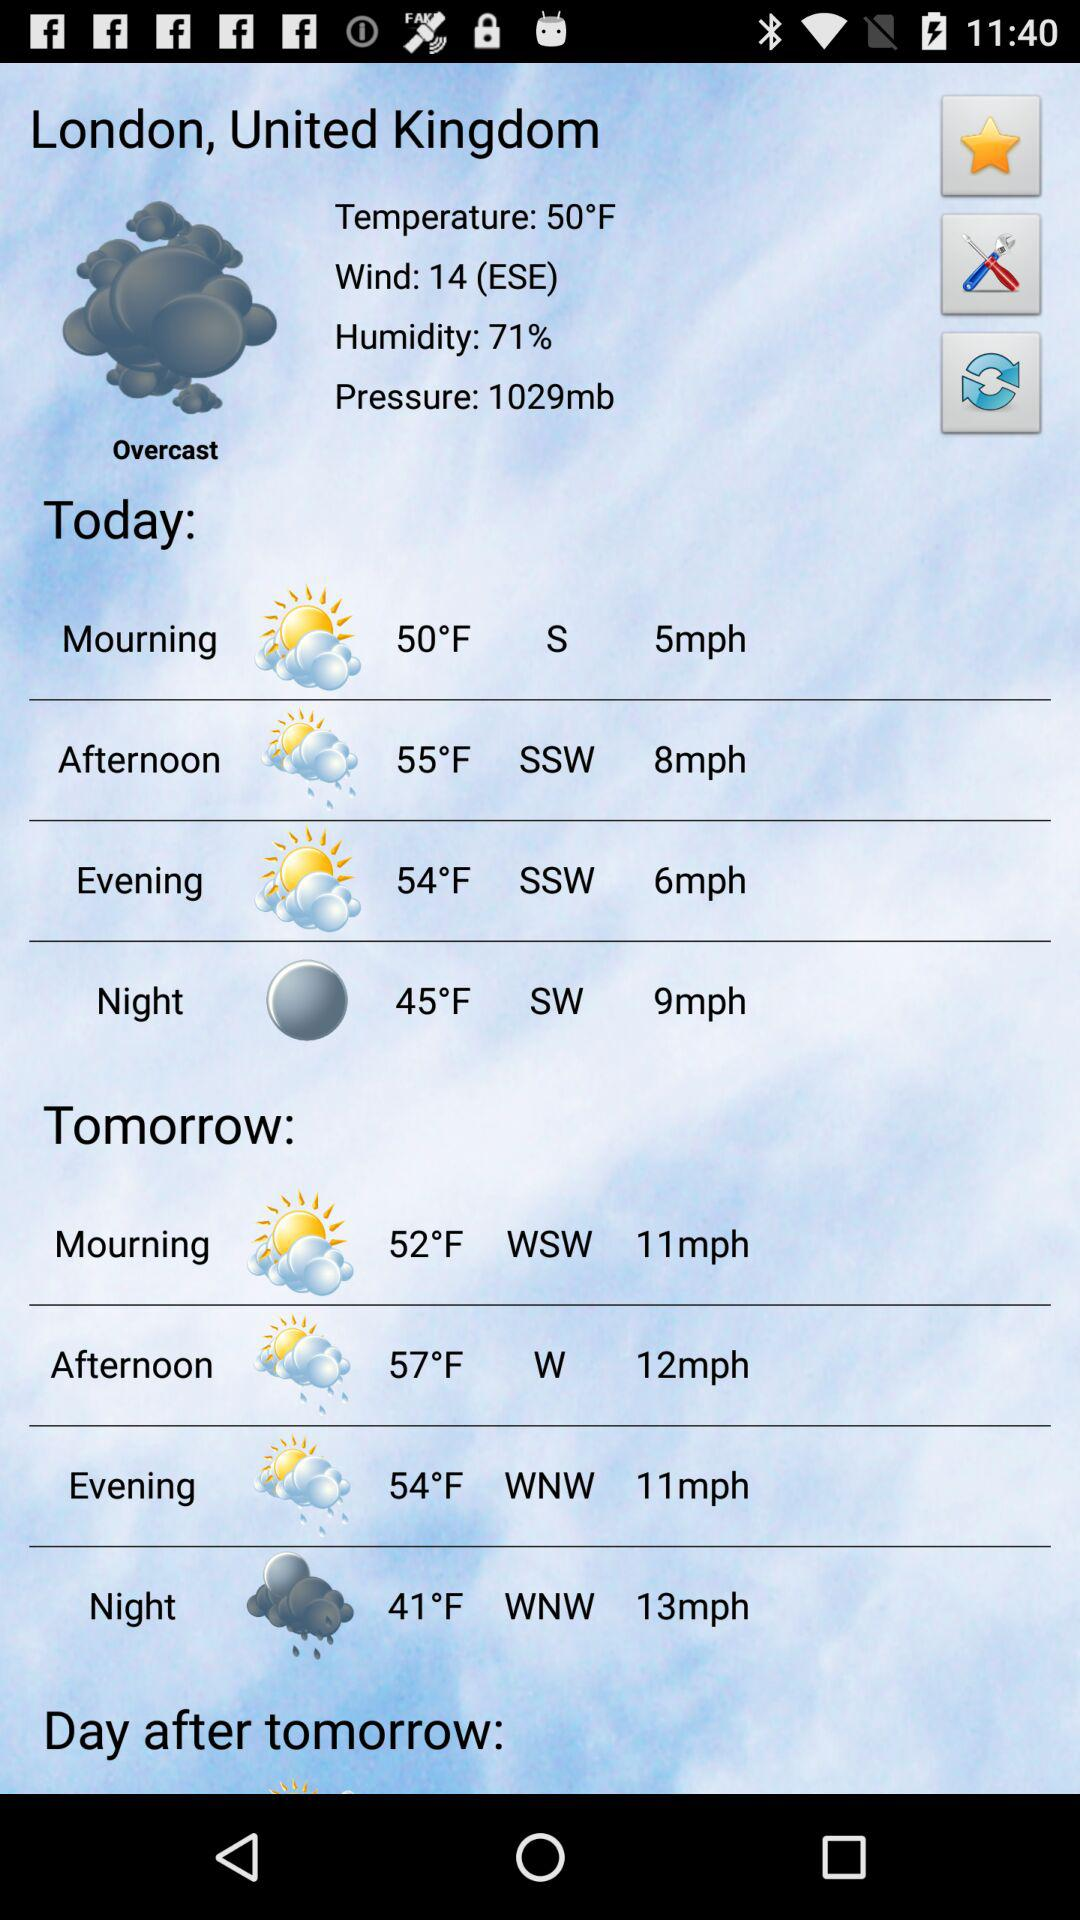How many degrees Fahrenheit is the lowest temperature for the next 3 days?
Answer the question using a single word or phrase. 41 